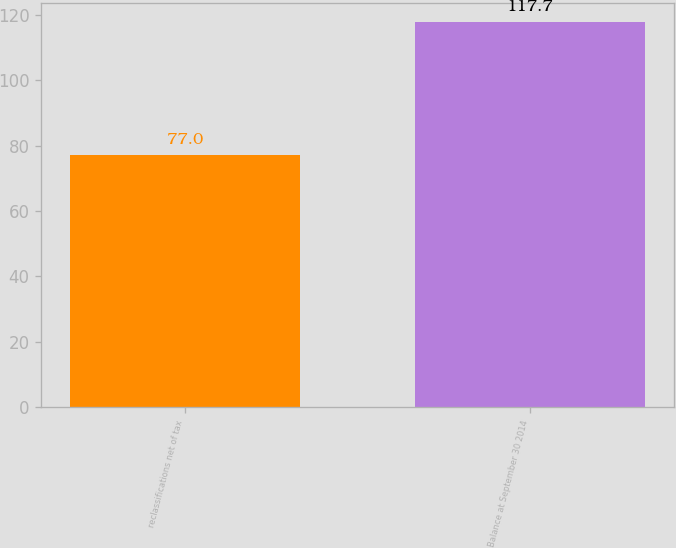Convert chart to OTSL. <chart><loc_0><loc_0><loc_500><loc_500><bar_chart><fcel>reclassifications net of tax<fcel>Balance at September 30 2014<nl><fcel>77<fcel>117.7<nl></chart> 